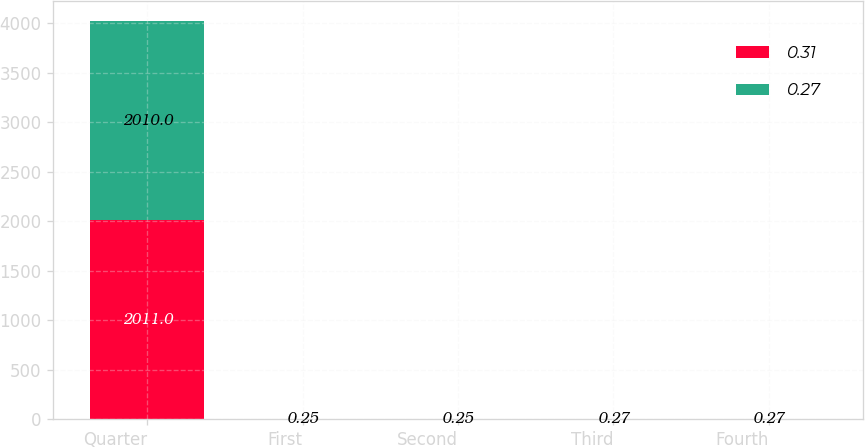Convert chart to OTSL. <chart><loc_0><loc_0><loc_500><loc_500><stacked_bar_chart><ecel><fcel>Quarter<fcel>First<fcel>Second<fcel>Third<fcel>Fourth<nl><fcel>0.31<fcel>2011<fcel>0.27<fcel>0.27<fcel>0.31<fcel>0.31<nl><fcel>0.27<fcel>2010<fcel>0.25<fcel>0.25<fcel>0.27<fcel>0.27<nl></chart> 